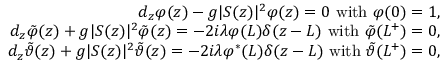Convert formula to latex. <formula><loc_0><loc_0><loc_500><loc_500>\begin{array} { r l r } & { d _ { z } \varphi ( z ) - g | S ( z ) | ^ { 2 } \varphi ( z ) = 0 \ w i t h \ \varphi ( 0 ) = 1 , } \\ & { d _ { z } \tilde { \varphi } ( z ) + g | S ( z ) | ^ { 2 } \tilde { \varphi } ( z ) = - 2 i \lambda \varphi ( L ) \delta ( z - L ) \ w i t h \ \tilde { \varphi } ( L ^ { + } ) = 0 , } \\ & { d _ { z } \tilde { \vartheta } ( z ) + g | S ( z ) | ^ { 2 } \tilde { \vartheta } ( z ) = - 2 i \lambda \varphi ^ { \ast } ( L ) \delta ( z - L ) \ w i t h \ \tilde { \vartheta } ( L ^ { + } ) = 0 , } \end{array}</formula> 